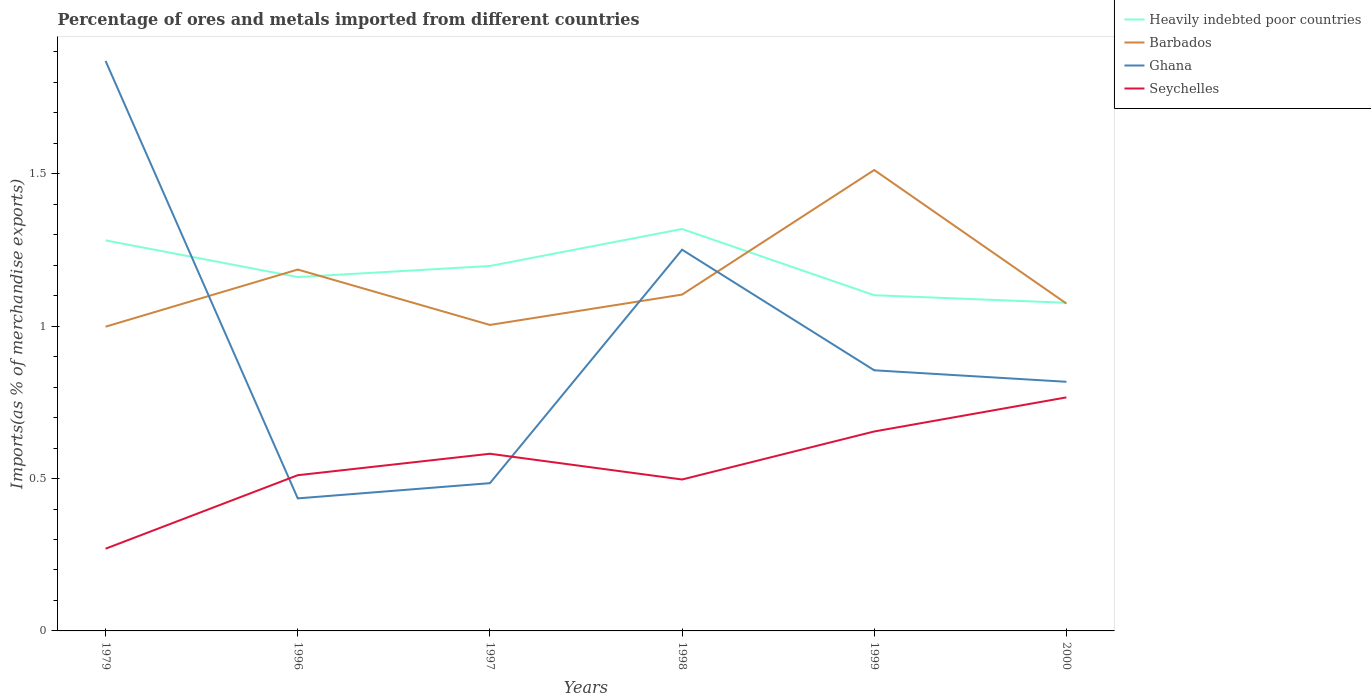How many different coloured lines are there?
Your response must be concise. 4. Is the number of lines equal to the number of legend labels?
Keep it short and to the point. Yes. Across all years, what is the maximum percentage of imports to different countries in Seychelles?
Your response must be concise. 0.27. What is the total percentage of imports to different countries in Heavily indebted poor countries in the graph?
Offer a terse response. 0.24. What is the difference between the highest and the second highest percentage of imports to different countries in Ghana?
Your answer should be compact. 1.44. What is the difference between the highest and the lowest percentage of imports to different countries in Seychelles?
Give a very brief answer. 3. How many lines are there?
Keep it short and to the point. 4. What is the difference between two consecutive major ticks on the Y-axis?
Your answer should be compact. 0.5. Does the graph contain any zero values?
Give a very brief answer. No. Does the graph contain grids?
Your response must be concise. No. Where does the legend appear in the graph?
Ensure brevity in your answer.  Top right. How many legend labels are there?
Your answer should be compact. 4. What is the title of the graph?
Give a very brief answer. Percentage of ores and metals imported from different countries. Does "Mali" appear as one of the legend labels in the graph?
Offer a very short reply. No. What is the label or title of the Y-axis?
Make the answer very short. Imports(as % of merchandise exports). What is the Imports(as % of merchandise exports) of Heavily indebted poor countries in 1979?
Ensure brevity in your answer.  1.28. What is the Imports(as % of merchandise exports) in Barbados in 1979?
Make the answer very short. 1. What is the Imports(as % of merchandise exports) of Ghana in 1979?
Your response must be concise. 1.87. What is the Imports(as % of merchandise exports) of Seychelles in 1979?
Offer a very short reply. 0.27. What is the Imports(as % of merchandise exports) in Heavily indebted poor countries in 1996?
Your answer should be compact. 1.16. What is the Imports(as % of merchandise exports) in Barbados in 1996?
Keep it short and to the point. 1.19. What is the Imports(as % of merchandise exports) in Ghana in 1996?
Offer a terse response. 0.43. What is the Imports(as % of merchandise exports) of Seychelles in 1996?
Keep it short and to the point. 0.51. What is the Imports(as % of merchandise exports) of Heavily indebted poor countries in 1997?
Provide a succinct answer. 1.2. What is the Imports(as % of merchandise exports) of Barbados in 1997?
Make the answer very short. 1. What is the Imports(as % of merchandise exports) of Ghana in 1997?
Offer a terse response. 0.48. What is the Imports(as % of merchandise exports) in Seychelles in 1997?
Provide a short and direct response. 0.58. What is the Imports(as % of merchandise exports) of Heavily indebted poor countries in 1998?
Your answer should be very brief. 1.32. What is the Imports(as % of merchandise exports) in Barbados in 1998?
Your response must be concise. 1.1. What is the Imports(as % of merchandise exports) of Ghana in 1998?
Give a very brief answer. 1.25. What is the Imports(as % of merchandise exports) in Seychelles in 1998?
Your answer should be compact. 0.5. What is the Imports(as % of merchandise exports) of Heavily indebted poor countries in 1999?
Provide a short and direct response. 1.1. What is the Imports(as % of merchandise exports) of Barbados in 1999?
Ensure brevity in your answer.  1.51. What is the Imports(as % of merchandise exports) in Ghana in 1999?
Your answer should be very brief. 0.86. What is the Imports(as % of merchandise exports) of Seychelles in 1999?
Provide a short and direct response. 0.65. What is the Imports(as % of merchandise exports) in Heavily indebted poor countries in 2000?
Keep it short and to the point. 1.08. What is the Imports(as % of merchandise exports) of Barbados in 2000?
Your answer should be very brief. 1.07. What is the Imports(as % of merchandise exports) of Ghana in 2000?
Offer a terse response. 0.82. What is the Imports(as % of merchandise exports) of Seychelles in 2000?
Provide a succinct answer. 0.77. Across all years, what is the maximum Imports(as % of merchandise exports) of Heavily indebted poor countries?
Provide a short and direct response. 1.32. Across all years, what is the maximum Imports(as % of merchandise exports) of Barbados?
Ensure brevity in your answer.  1.51. Across all years, what is the maximum Imports(as % of merchandise exports) in Ghana?
Your answer should be very brief. 1.87. Across all years, what is the maximum Imports(as % of merchandise exports) in Seychelles?
Provide a succinct answer. 0.77. Across all years, what is the minimum Imports(as % of merchandise exports) in Heavily indebted poor countries?
Provide a succinct answer. 1.08. Across all years, what is the minimum Imports(as % of merchandise exports) of Barbados?
Give a very brief answer. 1. Across all years, what is the minimum Imports(as % of merchandise exports) in Ghana?
Give a very brief answer. 0.43. Across all years, what is the minimum Imports(as % of merchandise exports) in Seychelles?
Provide a short and direct response. 0.27. What is the total Imports(as % of merchandise exports) of Heavily indebted poor countries in the graph?
Make the answer very short. 7.14. What is the total Imports(as % of merchandise exports) in Barbados in the graph?
Make the answer very short. 6.88. What is the total Imports(as % of merchandise exports) in Ghana in the graph?
Your answer should be compact. 5.71. What is the total Imports(as % of merchandise exports) of Seychelles in the graph?
Your response must be concise. 3.28. What is the difference between the Imports(as % of merchandise exports) of Heavily indebted poor countries in 1979 and that in 1996?
Your answer should be very brief. 0.12. What is the difference between the Imports(as % of merchandise exports) of Barbados in 1979 and that in 1996?
Provide a short and direct response. -0.19. What is the difference between the Imports(as % of merchandise exports) of Ghana in 1979 and that in 1996?
Offer a terse response. 1.44. What is the difference between the Imports(as % of merchandise exports) of Seychelles in 1979 and that in 1996?
Give a very brief answer. -0.24. What is the difference between the Imports(as % of merchandise exports) of Heavily indebted poor countries in 1979 and that in 1997?
Provide a succinct answer. 0.08. What is the difference between the Imports(as % of merchandise exports) in Barbados in 1979 and that in 1997?
Ensure brevity in your answer.  -0.01. What is the difference between the Imports(as % of merchandise exports) in Ghana in 1979 and that in 1997?
Offer a terse response. 1.39. What is the difference between the Imports(as % of merchandise exports) in Seychelles in 1979 and that in 1997?
Keep it short and to the point. -0.31. What is the difference between the Imports(as % of merchandise exports) of Heavily indebted poor countries in 1979 and that in 1998?
Give a very brief answer. -0.04. What is the difference between the Imports(as % of merchandise exports) of Barbados in 1979 and that in 1998?
Offer a terse response. -0.11. What is the difference between the Imports(as % of merchandise exports) in Ghana in 1979 and that in 1998?
Offer a terse response. 0.62. What is the difference between the Imports(as % of merchandise exports) of Seychelles in 1979 and that in 1998?
Provide a succinct answer. -0.23. What is the difference between the Imports(as % of merchandise exports) of Heavily indebted poor countries in 1979 and that in 1999?
Ensure brevity in your answer.  0.18. What is the difference between the Imports(as % of merchandise exports) in Barbados in 1979 and that in 1999?
Provide a short and direct response. -0.51. What is the difference between the Imports(as % of merchandise exports) in Ghana in 1979 and that in 1999?
Your response must be concise. 1.02. What is the difference between the Imports(as % of merchandise exports) of Seychelles in 1979 and that in 1999?
Keep it short and to the point. -0.38. What is the difference between the Imports(as % of merchandise exports) in Heavily indebted poor countries in 1979 and that in 2000?
Provide a succinct answer. 0.2. What is the difference between the Imports(as % of merchandise exports) of Barbados in 1979 and that in 2000?
Your response must be concise. -0.08. What is the difference between the Imports(as % of merchandise exports) in Ghana in 1979 and that in 2000?
Your answer should be compact. 1.05. What is the difference between the Imports(as % of merchandise exports) in Seychelles in 1979 and that in 2000?
Offer a terse response. -0.5. What is the difference between the Imports(as % of merchandise exports) of Heavily indebted poor countries in 1996 and that in 1997?
Offer a terse response. -0.04. What is the difference between the Imports(as % of merchandise exports) in Barbados in 1996 and that in 1997?
Your response must be concise. 0.18. What is the difference between the Imports(as % of merchandise exports) in Ghana in 1996 and that in 1997?
Provide a succinct answer. -0.05. What is the difference between the Imports(as % of merchandise exports) of Seychelles in 1996 and that in 1997?
Provide a short and direct response. -0.07. What is the difference between the Imports(as % of merchandise exports) in Heavily indebted poor countries in 1996 and that in 1998?
Keep it short and to the point. -0.16. What is the difference between the Imports(as % of merchandise exports) of Barbados in 1996 and that in 1998?
Ensure brevity in your answer.  0.08. What is the difference between the Imports(as % of merchandise exports) in Ghana in 1996 and that in 1998?
Keep it short and to the point. -0.82. What is the difference between the Imports(as % of merchandise exports) in Seychelles in 1996 and that in 1998?
Offer a very short reply. 0.01. What is the difference between the Imports(as % of merchandise exports) of Heavily indebted poor countries in 1996 and that in 1999?
Offer a terse response. 0.06. What is the difference between the Imports(as % of merchandise exports) in Barbados in 1996 and that in 1999?
Your response must be concise. -0.33. What is the difference between the Imports(as % of merchandise exports) of Ghana in 1996 and that in 1999?
Keep it short and to the point. -0.42. What is the difference between the Imports(as % of merchandise exports) of Seychelles in 1996 and that in 1999?
Provide a short and direct response. -0.14. What is the difference between the Imports(as % of merchandise exports) in Heavily indebted poor countries in 1996 and that in 2000?
Keep it short and to the point. 0.08. What is the difference between the Imports(as % of merchandise exports) of Barbados in 1996 and that in 2000?
Make the answer very short. 0.11. What is the difference between the Imports(as % of merchandise exports) in Ghana in 1996 and that in 2000?
Your answer should be compact. -0.38. What is the difference between the Imports(as % of merchandise exports) in Seychelles in 1996 and that in 2000?
Offer a very short reply. -0.26. What is the difference between the Imports(as % of merchandise exports) of Heavily indebted poor countries in 1997 and that in 1998?
Ensure brevity in your answer.  -0.12. What is the difference between the Imports(as % of merchandise exports) in Barbados in 1997 and that in 1998?
Give a very brief answer. -0.1. What is the difference between the Imports(as % of merchandise exports) of Ghana in 1997 and that in 1998?
Ensure brevity in your answer.  -0.77. What is the difference between the Imports(as % of merchandise exports) of Seychelles in 1997 and that in 1998?
Keep it short and to the point. 0.08. What is the difference between the Imports(as % of merchandise exports) of Heavily indebted poor countries in 1997 and that in 1999?
Give a very brief answer. 0.1. What is the difference between the Imports(as % of merchandise exports) of Barbados in 1997 and that in 1999?
Provide a short and direct response. -0.51. What is the difference between the Imports(as % of merchandise exports) of Ghana in 1997 and that in 1999?
Offer a very short reply. -0.37. What is the difference between the Imports(as % of merchandise exports) of Seychelles in 1997 and that in 1999?
Your answer should be very brief. -0.07. What is the difference between the Imports(as % of merchandise exports) in Heavily indebted poor countries in 1997 and that in 2000?
Make the answer very short. 0.12. What is the difference between the Imports(as % of merchandise exports) in Barbados in 1997 and that in 2000?
Your answer should be very brief. -0.07. What is the difference between the Imports(as % of merchandise exports) in Ghana in 1997 and that in 2000?
Provide a succinct answer. -0.33. What is the difference between the Imports(as % of merchandise exports) of Seychelles in 1997 and that in 2000?
Your response must be concise. -0.18. What is the difference between the Imports(as % of merchandise exports) of Heavily indebted poor countries in 1998 and that in 1999?
Your answer should be very brief. 0.22. What is the difference between the Imports(as % of merchandise exports) of Barbados in 1998 and that in 1999?
Give a very brief answer. -0.41. What is the difference between the Imports(as % of merchandise exports) of Ghana in 1998 and that in 1999?
Your response must be concise. 0.4. What is the difference between the Imports(as % of merchandise exports) of Seychelles in 1998 and that in 1999?
Make the answer very short. -0.16. What is the difference between the Imports(as % of merchandise exports) of Heavily indebted poor countries in 1998 and that in 2000?
Give a very brief answer. 0.24. What is the difference between the Imports(as % of merchandise exports) of Barbados in 1998 and that in 2000?
Provide a succinct answer. 0.03. What is the difference between the Imports(as % of merchandise exports) in Ghana in 1998 and that in 2000?
Give a very brief answer. 0.43. What is the difference between the Imports(as % of merchandise exports) of Seychelles in 1998 and that in 2000?
Make the answer very short. -0.27. What is the difference between the Imports(as % of merchandise exports) of Heavily indebted poor countries in 1999 and that in 2000?
Your response must be concise. 0.02. What is the difference between the Imports(as % of merchandise exports) in Barbados in 1999 and that in 2000?
Provide a short and direct response. 0.44. What is the difference between the Imports(as % of merchandise exports) of Ghana in 1999 and that in 2000?
Offer a terse response. 0.04. What is the difference between the Imports(as % of merchandise exports) of Seychelles in 1999 and that in 2000?
Offer a terse response. -0.11. What is the difference between the Imports(as % of merchandise exports) of Heavily indebted poor countries in 1979 and the Imports(as % of merchandise exports) of Barbados in 1996?
Give a very brief answer. 0.1. What is the difference between the Imports(as % of merchandise exports) of Heavily indebted poor countries in 1979 and the Imports(as % of merchandise exports) of Ghana in 1996?
Provide a short and direct response. 0.85. What is the difference between the Imports(as % of merchandise exports) in Heavily indebted poor countries in 1979 and the Imports(as % of merchandise exports) in Seychelles in 1996?
Your response must be concise. 0.77. What is the difference between the Imports(as % of merchandise exports) in Barbados in 1979 and the Imports(as % of merchandise exports) in Ghana in 1996?
Your response must be concise. 0.56. What is the difference between the Imports(as % of merchandise exports) in Barbados in 1979 and the Imports(as % of merchandise exports) in Seychelles in 1996?
Your response must be concise. 0.49. What is the difference between the Imports(as % of merchandise exports) in Ghana in 1979 and the Imports(as % of merchandise exports) in Seychelles in 1996?
Offer a terse response. 1.36. What is the difference between the Imports(as % of merchandise exports) in Heavily indebted poor countries in 1979 and the Imports(as % of merchandise exports) in Barbados in 1997?
Provide a succinct answer. 0.28. What is the difference between the Imports(as % of merchandise exports) of Heavily indebted poor countries in 1979 and the Imports(as % of merchandise exports) of Ghana in 1997?
Give a very brief answer. 0.8. What is the difference between the Imports(as % of merchandise exports) of Heavily indebted poor countries in 1979 and the Imports(as % of merchandise exports) of Seychelles in 1997?
Make the answer very short. 0.7. What is the difference between the Imports(as % of merchandise exports) in Barbados in 1979 and the Imports(as % of merchandise exports) in Ghana in 1997?
Keep it short and to the point. 0.51. What is the difference between the Imports(as % of merchandise exports) of Barbados in 1979 and the Imports(as % of merchandise exports) of Seychelles in 1997?
Keep it short and to the point. 0.42. What is the difference between the Imports(as % of merchandise exports) in Ghana in 1979 and the Imports(as % of merchandise exports) in Seychelles in 1997?
Give a very brief answer. 1.29. What is the difference between the Imports(as % of merchandise exports) in Heavily indebted poor countries in 1979 and the Imports(as % of merchandise exports) in Barbados in 1998?
Ensure brevity in your answer.  0.18. What is the difference between the Imports(as % of merchandise exports) of Heavily indebted poor countries in 1979 and the Imports(as % of merchandise exports) of Ghana in 1998?
Offer a terse response. 0.03. What is the difference between the Imports(as % of merchandise exports) in Heavily indebted poor countries in 1979 and the Imports(as % of merchandise exports) in Seychelles in 1998?
Keep it short and to the point. 0.78. What is the difference between the Imports(as % of merchandise exports) in Barbados in 1979 and the Imports(as % of merchandise exports) in Ghana in 1998?
Your answer should be compact. -0.25. What is the difference between the Imports(as % of merchandise exports) in Barbados in 1979 and the Imports(as % of merchandise exports) in Seychelles in 1998?
Make the answer very short. 0.5. What is the difference between the Imports(as % of merchandise exports) in Ghana in 1979 and the Imports(as % of merchandise exports) in Seychelles in 1998?
Your answer should be very brief. 1.37. What is the difference between the Imports(as % of merchandise exports) of Heavily indebted poor countries in 1979 and the Imports(as % of merchandise exports) of Barbados in 1999?
Provide a succinct answer. -0.23. What is the difference between the Imports(as % of merchandise exports) in Heavily indebted poor countries in 1979 and the Imports(as % of merchandise exports) in Ghana in 1999?
Provide a succinct answer. 0.43. What is the difference between the Imports(as % of merchandise exports) in Heavily indebted poor countries in 1979 and the Imports(as % of merchandise exports) in Seychelles in 1999?
Give a very brief answer. 0.63. What is the difference between the Imports(as % of merchandise exports) of Barbados in 1979 and the Imports(as % of merchandise exports) of Ghana in 1999?
Offer a terse response. 0.14. What is the difference between the Imports(as % of merchandise exports) in Barbados in 1979 and the Imports(as % of merchandise exports) in Seychelles in 1999?
Make the answer very short. 0.34. What is the difference between the Imports(as % of merchandise exports) of Ghana in 1979 and the Imports(as % of merchandise exports) of Seychelles in 1999?
Provide a short and direct response. 1.22. What is the difference between the Imports(as % of merchandise exports) of Heavily indebted poor countries in 1979 and the Imports(as % of merchandise exports) of Barbados in 2000?
Your response must be concise. 0.21. What is the difference between the Imports(as % of merchandise exports) in Heavily indebted poor countries in 1979 and the Imports(as % of merchandise exports) in Ghana in 2000?
Provide a short and direct response. 0.46. What is the difference between the Imports(as % of merchandise exports) in Heavily indebted poor countries in 1979 and the Imports(as % of merchandise exports) in Seychelles in 2000?
Provide a succinct answer. 0.52. What is the difference between the Imports(as % of merchandise exports) in Barbados in 1979 and the Imports(as % of merchandise exports) in Ghana in 2000?
Your response must be concise. 0.18. What is the difference between the Imports(as % of merchandise exports) in Barbados in 1979 and the Imports(as % of merchandise exports) in Seychelles in 2000?
Ensure brevity in your answer.  0.23. What is the difference between the Imports(as % of merchandise exports) in Ghana in 1979 and the Imports(as % of merchandise exports) in Seychelles in 2000?
Your response must be concise. 1.1. What is the difference between the Imports(as % of merchandise exports) of Heavily indebted poor countries in 1996 and the Imports(as % of merchandise exports) of Barbados in 1997?
Ensure brevity in your answer.  0.16. What is the difference between the Imports(as % of merchandise exports) of Heavily indebted poor countries in 1996 and the Imports(as % of merchandise exports) of Ghana in 1997?
Provide a short and direct response. 0.68. What is the difference between the Imports(as % of merchandise exports) in Heavily indebted poor countries in 1996 and the Imports(as % of merchandise exports) in Seychelles in 1997?
Make the answer very short. 0.58. What is the difference between the Imports(as % of merchandise exports) in Barbados in 1996 and the Imports(as % of merchandise exports) in Ghana in 1997?
Your answer should be compact. 0.7. What is the difference between the Imports(as % of merchandise exports) in Barbados in 1996 and the Imports(as % of merchandise exports) in Seychelles in 1997?
Your answer should be very brief. 0.6. What is the difference between the Imports(as % of merchandise exports) of Ghana in 1996 and the Imports(as % of merchandise exports) of Seychelles in 1997?
Make the answer very short. -0.15. What is the difference between the Imports(as % of merchandise exports) of Heavily indebted poor countries in 1996 and the Imports(as % of merchandise exports) of Barbados in 1998?
Provide a short and direct response. 0.06. What is the difference between the Imports(as % of merchandise exports) of Heavily indebted poor countries in 1996 and the Imports(as % of merchandise exports) of Ghana in 1998?
Provide a succinct answer. -0.09. What is the difference between the Imports(as % of merchandise exports) of Heavily indebted poor countries in 1996 and the Imports(as % of merchandise exports) of Seychelles in 1998?
Ensure brevity in your answer.  0.66. What is the difference between the Imports(as % of merchandise exports) of Barbados in 1996 and the Imports(as % of merchandise exports) of Ghana in 1998?
Keep it short and to the point. -0.07. What is the difference between the Imports(as % of merchandise exports) in Barbados in 1996 and the Imports(as % of merchandise exports) in Seychelles in 1998?
Your response must be concise. 0.69. What is the difference between the Imports(as % of merchandise exports) in Ghana in 1996 and the Imports(as % of merchandise exports) in Seychelles in 1998?
Keep it short and to the point. -0.06. What is the difference between the Imports(as % of merchandise exports) in Heavily indebted poor countries in 1996 and the Imports(as % of merchandise exports) in Barbados in 1999?
Your response must be concise. -0.35. What is the difference between the Imports(as % of merchandise exports) in Heavily indebted poor countries in 1996 and the Imports(as % of merchandise exports) in Ghana in 1999?
Give a very brief answer. 0.31. What is the difference between the Imports(as % of merchandise exports) in Heavily indebted poor countries in 1996 and the Imports(as % of merchandise exports) in Seychelles in 1999?
Provide a succinct answer. 0.51. What is the difference between the Imports(as % of merchandise exports) of Barbados in 1996 and the Imports(as % of merchandise exports) of Ghana in 1999?
Your answer should be very brief. 0.33. What is the difference between the Imports(as % of merchandise exports) in Barbados in 1996 and the Imports(as % of merchandise exports) in Seychelles in 1999?
Your answer should be compact. 0.53. What is the difference between the Imports(as % of merchandise exports) of Ghana in 1996 and the Imports(as % of merchandise exports) of Seychelles in 1999?
Make the answer very short. -0.22. What is the difference between the Imports(as % of merchandise exports) in Heavily indebted poor countries in 1996 and the Imports(as % of merchandise exports) in Barbados in 2000?
Make the answer very short. 0.09. What is the difference between the Imports(as % of merchandise exports) in Heavily indebted poor countries in 1996 and the Imports(as % of merchandise exports) in Ghana in 2000?
Provide a short and direct response. 0.34. What is the difference between the Imports(as % of merchandise exports) of Heavily indebted poor countries in 1996 and the Imports(as % of merchandise exports) of Seychelles in 2000?
Your answer should be very brief. 0.39. What is the difference between the Imports(as % of merchandise exports) of Barbados in 1996 and the Imports(as % of merchandise exports) of Ghana in 2000?
Your response must be concise. 0.37. What is the difference between the Imports(as % of merchandise exports) of Barbados in 1996 and the Imports(as % of merchandise exports) of Seychelles in 2000?
Your answer should be compact. 0.42. What is the difference between the Imports(as % of merchandise exports) in Ghana in 1996 and the Imports(as % of merchandise exports) in Seychelles in 2000?
Give a very brief answer. -0.33. What is the difference between the Imports(as % of merchandise exports) of Heavily indebted poor countries in 1997 and the Imports(as % of merchandise exports) of Barbados in 1998?
Offer a very short reply. 0.09. What is the difference between the Imports(as % of merchandise exports) of Heavily indebted poor countries in 1997 and the Imports(as % of merchandise exports) of Ghana in 1998?
Offer a very short reply. -0.05. What is the difference between the Imports(as % of merchandise exports) of Heavily indebted poor countries in 1997 and the Imports(as % of merchandise exports) of Seychelles in 1998?
Provide a short and direct response. 0.7. What is the difference between the Imports(as % of merchandise exports) in Barbados in 1997 and the Imports(as % of merchandise exports) in Ghana in 1998?
Provide a succinct answer. -0.25. What is the difference between the Imports(as % of merchandise exports) in Barbados in 1997 and the Imports(as % of merchandise exports) in Seychelles in 1998?
Give a very brief answer. 0.51. What is the difference between the Imports(as % of merchandise exports) of Ghana in 1997 and the Imports(as % of merchandise exports) of Seychelles in 1998?
Offer a terse response. -0.01. What is the difference between the Imports(as % of merchandise exports) of Heavily indebted poor countries in 1997 and the Imports(as % of merchandise exports) of Barbados in 1999?
Offer a very short reply. -0.31. What is the difference between the Imports(as % of merchandise exports) in Heavily indebted poor countries in 1997 and the Imports(as % of merchandise exports) in Ghana in 1999?
Make the answer very short. 0.34. What is the difference between the Imports(as % of merchandise exports) of Heavily indebted poor countries in 1997 and the Imports(as % of merchandise exports) of Seychelles in 1999?
Provide a short and direct response. 0.54. What is the difference between the Imports(as % of merchandise exports) of Barbados in 1997 and the Imports(as % of merchandise exports) of Ghana in 1999?
Provide a short and direct response. 0.15. What is the difference between the Imports(as % of merchandise exports) in Barbados in 1997 and the Imports(as % of merchandise exports) in Seychelles in 1999?
Provide a succinct answer. 0.35. What is the difference between the Imports(as % of merchandise exports) of Ghana in 1997 and the Imports(as % of merchandise exports) of Seychelles in 1999?
Provide a short and direct response. -0.17. What is the difference between the Imports(as % of merchandise exports) of Heavily indebted poor countries in 1997 and the Imports(as % of merchandise exports) of Barbados in 2000?
Offer a very short reply. 0.12. What is the difference between the Imports(as % of merchandise exports) in Heavily indebted poor countries in 1997 and the Imports(as % of merchandise exports) in Ghana in 2000?
Your answer should be compact. 0.38. What is the difference between the Imports(as % of merchandise exports) in Heavily indebted poor countries in 1997 and the Imports(as % of merchandise exports) in Seychelles in 2000?
Provide a short and direct response. 0.43. What is the difference between the Imports(as % of merchandise exports) of Barbados in 1997 and the Imports(as % of merchandise exports) of Ghana in 2000?
Your answer should be very brief. 0.19. What is the difference between the Imports(as % of merchandise exports) in Barbados in 1997 and the Imports(as % of merchandise exports) in Seychelles in 2000?
Ensure brevity in your answer.  0.24. What is the difference between the Imports(as % of merchandise exports) in Ghana in 1997 and the Imports(as % of merchandise exports) in Seychelles in 2000?
Your response must be concise. -0.28. What is the difference between the Imports(as % of merchandise exports) in Heavily indebted poor countries in 1998 and the Imports(as % of merchandise exports) in Barbados in 1999?
Your answer should be compact. -0.19. What is the difference between the Imports(as % of merchandise exports) in Heavily indebted poor countries in 1998 and the Imports(as % of merchandise exports) in Ghana in 1999?
Your answer should be compact. 0.46. What is the difference between the Imports(as % of merchandise exports) in Heavily indebted poor countries in 1998 and the Imports(as % of merchandise exports) in Seychelles in 1999?
Give a very brief answer. 0.66. What is the difference between the Imports(as % of merchandise exports) in Barbados in 1998 and the Imports(as % of merchandise exports) in Ghana in 1999?
Your answer should be very brief. 0.25. What is the difference between the Imports(as % of merchandise exports) of Barbados in 1998 and the Imports(as % of merchandise exports) of Seychelles in 1999?
Offer a very short reply. 0.45. What is the difference between the Imports(as % of merchandise exports) in Ghana in 1998 and the Imports(as % of merchandise exports) in Seychelles in 1999?
Offer a terse response. 0.6. What is the difference between the Imports(as % of merchandise exports) of Heavily indebted poor countries in 1998 and the Imports(as % of merchandise exports) of Barbados in 2000?
Offer a very short reply. 0.24. What is the difference between the Imports(as % of merchandise exports) of Heavily indebted poor countries in 1998 and the Imports(as % of merchandise exports) of Ghana in 2000?
Give a very brief answer. 0.5. What is the difference between the Imports(as % of merchandise exports) of Heavily indebted poor countries in 1998 and the Imports(as % of merchandise exports) of Seychelles in 2000?
Offer a terse response. 0.55. What is the difference between the Imports(as % of merchandise exports) of Barbados in 1998 and the Imports(as % of merchandise exports) of Ghana in 2000?
Your response must be concise. 0.29. What is the difference between the Imports(as % of merchandise exports) of Barbados in 1998 and the Imports(as % of merchandise exports) of Seychelles in 2000?
Make the answer very short. 0.34. What is the difference between the Imports(as % of merchandise exports) of Ghana in 1998 and the Imports(as % of merchandise exports) of Seychelles in 2000?
Provide a short and direct response. 0.48. What is the difference between the Imports(as % of merchandise exports) of Heavily indebted poor countries in 1999 and the Imports(as % of merchandise exports) of Barbados in 2000?
Keep it short and to the point. 0.03. What is the difference between the Imports(as % of merchandise exports) in Heavily indebted poor countries in 1999 and the Imports(as % of merchandise exports) in Ghana in 2000?
Keep it short and to the point. 0.28. What is the difference between the Imports(as % of merchandise exports) of Heavily indebted poor countries in 1999 and the Imports(as % of merchandise exports) of Seychelles in 2000?
Give a very brief answer. 0.34. What is the difference between the Imports(as % of merchandise exports) in Barbados in 1999 and the Imports(as % of merchandise exports) in Ghana in 2000?
Provide a succinct answer. 0.69. What is the difference between the Imports(as % of merchandise exports) in Barbados in 1999 and the Imports(as % of merchandise exports) in Seychelles in 2000?
Give a very brief answer. 0.75. What is the difference between the Imports(as % of merchandise exports) of Ghana in 1999 and the Imports(as % of merchandise exports) of Seychelles in 2000?
Offer a terse response. 0.09. What is the average Imports(as % of merchandise exports) in Heavily indebted poor countries per year?
Make the answer very short. 1.19. What is the average Imports(as % of merchandise exports) of Barbados per year?
Your answer should be very brief. 1.15. What is the average Imports(as % of merchandise exports) in Seychelles per year?
Offer a very short reply. 0.55. In the year 1979, what is the difference between the Imports(as % of merchandise exports) of Heavily indebted poor countries and Imports(as % of merchandise exports) of Barbados?
Provide a short and direct response. 0.28. In the year 1979, what is the difference between the Imports(as % of merchandise exports) in Heavily indebted poor countries and Imports(as % of merchandise exports) in Ghana?
Your response must be concise. -0.59. In the year 1979, what is the difference between the Imports(as % of merchandise exports) of Heavily indebted poor countries and Imports(as % of merchandise exports) of Seychelles?
Offer a very short reply. 1.01. In the year 1979, what is the difference between the Imports(as % of merchandise exports) of Barbados and Imports(as % of merchandise exports) of Ghana?
Provide a succinct answer. -0.87. In the year 1979, what is the difference between the Imports(as % of merchandise exports) in Barbados and Imports(as % of merchandise exports) in Seychelles?
Make the answer very short. 0.73. In the year 1979, what is the difference between the Imports(as % of merchandise exports) of Ghana and Imports(as % of merchandise exports) of Seychelles?
Provide a succinct answer. 1.6. In the year 1996, what is the difference between the Imports(as % of merchandise exports) of Heavily indebted poor countries and Imports(as % of merchandise exports) of Barbados?
Your answer should be very brief. -0.02. In the year 1996, what is the difference between the Imports(as % of merchandise exports) in Heavily indebted poor countries and Imports(as % of merchandise exports) in Ghana?
Keep it short and to the point. 0.73. In the year 1996, what is the difference between the Imports(as % of merchandise exports) in Heavily indebted poor countries and Imports(as % of merchandise exports) in Seychelles?
Offer a terse response. 0.65. In the year 1996, what is the difference between the Imports(as % of merchandise exports) in Barbados and Imports(as % of merchandise exports) in Ghana?
Provide a short and direct response. 0.75. In the year 1996, what is the difference between the Imports(as % of merchandise exports) of Barbados and Imports(as % of merchandise exports) of Seychelles?
Give a very brief answer. 0.67. In the year 1996, what is the difference between the Imports(as % of merchandise exports) in Ghana and Imports(as % of merchandise exports) in Seychelles?
Offer a very short reply. -0.08. In the year 1997, what is the difference between the Imports(as % of merchandise exports) of Heavily indebted poor countries and Imports(as % of merchandise exports) of Barbados?
Provide a short and direct response. 0.19. In the year 1997, what is the difference between the Imports(as % of merchandise exports) in Heavily indebted poor countries and Imports(as % of merchandise exports) in Ghana?
Keep it short and to the point. 0.71. In the year 1997, what is the difference between the Imports(as % of merchandise exports) of Heavily indebted poor countries and Imports(as % of merchandise exports) of Seychelles?
Give a very brief answer. 0.62. In the year 1997, what is the difference between the Imports(as % of merchandise exports) in Barbados and Imports(as % of merchandise exports) in Ghana?
Offer a very short reply. 0.52. In the year 1997, what is the difference between the Imports(as % of merchandise exports) of Barbados and Imports(as % of merchandise exports) of Seychelles?
Your response must be concise. 0.42. In the year 1997, what is the difference between the Imports(as % of merchandise exports) in Ghana and Imports(as % of merchandise exports) in Seychelles?
Make the answer very short. -0.1. In the year 1998, what is the difference between the Imports(as % of merchandise exports) of Heavily indebted poor countries and Imports(as % of merchandise exports) of Barbados?
Give a very brief answer. 0.22. In the year 1998, what is the difference between the Imports(as % of merchandise exports) of Heavily indebted poor countries and Imports(as % of merchandise exports) of Ghana?
Make the answer very short. 0.07. In the year 1998, what is the difference between the Imports(as % of merchandise exports) of Heavily indebted poor countries and Imports(as % of merchandise exports) of Seychelles?
Keep it short and to the point. 0.82. In the year 1998, what is the difference between the Imports(as % of merchandise exports) in Barbados and Imports(as % of merchandise exports) in Ghana?
Provide a succinct answer. -0.15. In the year 1998, what is the difference between the Imports(as % of merchandise exports) in Barbados and Imports(as % of merchandise exports) in Seychelles?
Offer a very short reply. 0.61. In the year 1998, what is the difference between the Imports(as % of merchandise exports) of Ghana and Imports(as % of merchandise exports) of Seychelles?
Your answer should be very brief. 0.75. In the year 1999, what is the difference between the Imports(as % of merchandise exports) of Heavily indebted poor countries and Imports(as % of merchandise exports) of Barbados?
Keep it short and to the point. -0.41. In the year 1999, what is the difference between the Imports(as % of merchandise exports) in Heavily indebted poor countries and Imports(as % of merchandise exports) in Ghana?
Keep it short and to the point. 0.25. In the year 1999, what is the difference between the Imports(as % of merchandise exports) in Heavily indebted poor countries and Imports(as % of merchandise exports) in Seychelles?
Provide a short and direct response. 0.45. In the year 1999, what is the difference between the Imports(as % of merchandise exports) of Barbados and Imports(as % of merchandise exports) of Ghana?
Provide a succinct answer. 0.66. In the year 1999, what is the difference between the Imports(as % of merchandise exports) in Barbados and Imports(as % of merchandise exports) in Seychelles?
Make the answer very short. 0.86. In the year 1999, what is the difference between the Imports(as % of merchandise exports) in Ghana and Imports(as % of merchandise exports) in Seychelles?
Your answer should be very brief. 0.2. In the year 2000, what is the difference between the Imports(as % of merchandise exports) of Heavily indebted poor countries and Imports(as % of merchandise exports) of Barbados?
Make the answer very short. 0. In the year 2000, what is the difference between the Imports(as % of merchandise exports) of Heavily indebted poor countries and Imports(as % of merchandise exports) of Ghana?
Your answer should be compact. 0.26. In the year 2000, what is the difference between the Imports(as % of merchandise exports) in Heavily indebted poor countries and Imports(as % of merchandise exports) in Seychelles?
Make the answer very short. 0.31. In the year 2000, what is the difference between the Imports(as % of merchandise exports) of Barbados and Imports(as % of merchandise exports) of Ghana?
Offer a terse response. 0.26. In the year 2000, what is the difference between the Imports(as % of merchandise exports) in Barbados and Imports(as % of merchandise exports) in Seychelles?
Make the answer very short. 0.31. In the year 2000, what is the difference between the Imports(as % of merchandise exports) of Ghana and Imports(as % of merchandise exports) of Seychelles?
Your answer should be compact. 0.05. What is the ratio of the Imports(as % of merchandise exports) in Heavily indebted poor countries in 1979 to that in 1996?
Provide a short and direct response. 1.1. What is the ratio of the Imports(as % of merchandise exports) of Barbados in 1979 to that in 1996?
Provide a short and direct response. 0.84. What is the ratio of the Imports(as % of merchandise exports) in Ghana in 1979 to that in 1996?
Give a very brief answer. 4.3. What is the ratio of the Imports(as % of merchandise exports) in Seychelles in 1979 to that in 1996?
Your answer should be very brief. 0.53. What is the ratio of the Imports(as % of merchandise exports) of Heavily indebted poor countries in 1979 to that in 1997?
Your answer should be compact. 1.07. What is the ratio of the Imports(as % of merchandise exports) of Barbados in 1979 to that in 1997?
Offer a terse response. 0.99. What is the ratio of the Imports(as % of merchandise exports) of Ghana in 1979 to that in 1997?
Provide a short and direct response. 3.86. What is the ratio of the Imports(as % of merchandise exports) of Seychelles in 1979 to that in 1997?
Keep it short and to the point. 0.46. What is the ratio of the Imports(as % of merchandise exports) of Heavily indebted poor countries in 1979 to that in 1998?
Make the answer very short. 0.97. What is the ratio of the Imports(as % of merchandise exports) in Barbados in 1979 to that in 1998?
Offer a terse response. 0.9. What is the ratio of the Imports(as % of merchandise exports) in Ghana in 1979 to that in 1998?
Keep it short and to the point. 1.5. What is the ratio of the Imports(as % of merchandise exports) of Seychelles in 1979 to that in 1998?
Your answer should be very brief. 0.54. What is the ratio of the Imports(as % of merchandise exports) of Heavily indebted poor countries in 1979 to that in 1999?
Give a very brief answer. 1.16. What is the ratio of the Imports(as % of merchandise exports) of Barbados in 1979 to that in 1999?
Ensure brevity in your answer.  0.66. What is the ratio of the Imports(as % of merchandise exports) of Ghana in 1979 to that in 1999?
Provide a succinct answer. 2.19. What is the ratio of the Imports(as % of merchandise exports) of Seychelles in 1979 to that in 1999?
Your answer should be compact. 0.41. What is the ratio of the Imports(as % of merchandise exports) of Heavily indebted poor countries in 1979 to that in 2000?
Ensure brevity in your answer.  1.19. What is the ratio of the Imports(as % of merchandise exports) in Barbados in 1979 to that in 2000?
Provide a short and direct response. 0.93. What is the ratio of the Imports(as % of merchandise exports) in Ghana in 1979 to that in 2000?
Your answer should be compact. 2.29. What is the ratio of the Imports(as % of merchandise exports) of Seychelles in 1979 to that in 2000?
Ensure brevity in your answer.  0.35. What is the ratio of the Imports(as % of merchandise exports) in Heavily indebted poor countries in 1996 to that in 1997?
Your answer should be very brief. 0.97. What is the ratio of the Imports(as % of merchandise exports) in Barbados in 1996 to that in 1997?
Your response must be concise. 1.18. What is the ratio of the Imports(as % of merchandise exports) in Ghana in 1996 to that in 1997?
Keep it short and to the point. 0.9. What is the ratio of the Imports(as % of merchandise exports) in Seychelles in 1996 to that in 1997?
Provide a short and direct response. 0.88. What is the ratio of the Imports(as % of merchandise exports) of Heavily indebted poor countries in 1996 to that in 1998?
Offer a terse response. 0.88. What is the ratio of the Imports(as % of merchandise exports) in Barbados in 1996 to that in 1998?
Offer a very short reply. 1.07. What is the ratio of the Imports(as % of merchandise exports) in Ghana in 1996 to that in 1998?
Your response must be concise. 0.35. What is the ratio of the Imports(as % of merchandise exports) in Seychelles in 1996 to that in 1998?
Offer a terse response. 1.03. What is the ratio of the Imports(as % of merchandise exports) of Heavily indebted poor countries in 1996 to that in 1999?
Offer a terse response. 1.05. What is the ratio of the Imports(as % of merchandise exports) in Barbados in 1996 to that in 1999?
Offer a very short reply. 0.78. What is the ratio of the Imports(as % of merchandise exports) in Ghana in 1996 to that in 1999?
Your response must be concise. 0.51. What is the ratio of the Imports(as % of merchandise exports) of Seychelles in 1996 to that in 1999?
Your response must be concise. 0.78. What is the ratio of the Imports(as % of merchandise exports) of Heavily indebted poor countries in 1996 to that in 2000?
Offer a terse response. 1.08. What is the ratio of the Imports(as % of merchandise exports) of Barbados in 1996 to that in 2000?
Provide a short and direct response. 1.1. What is the ratio of the Imports(as % of merchandise exports) of Ghana in 1996 to that in 2000?
Your answer should be compact. 0.53. What is the ratio of the Imports(as % of merchandise exports) of Seychelles in 1996 to that in 2000?
Give a very brief answer. 0.67. What is the ratio of the Imports(as % of merchandise exports) in Heavily indebted poor countries in 1997 to that in 1998?
Offer a terse response. 0.91. What is the ratio of the Imports(as % of merchandise exports) in Barbados in 1997 to that in 1998?
Ensure brevity in your answer.  0.91. What is the ratio of the Imports(as % of merchandise exports) in Ghana in 1997 to that in 1998?
Ensure brevity in your answer.  0.39. What is the ratio of the Imports(as % of merchandise exports) of Seychelles in 1997 to that in 1998?
Provide a short and direct response. 1.17. What is the ratio of the Imports(as % of merchandise exports) in Heavily indebted poor countries in 1997 to that in 1999?
Your answer should be very brief. 1.09. What is the ratio of the Imports(as % of merchandise exports) of Barbados in 1997 to that in 1999?
Offer a terse response. 0.66. What is the ratio of the Imports(as % of merchandise exports) in Ghana in 1997 to that in 1999?
Keep it short and to the point. 0.57. What is the ratio of the Imports(as % of merchandise exports) in Seychelles in 1997 to that in 1999?
Your answer should be compact. 0.89. What is the ratio of the Imports(as % of merchandise exports) of Heavily indebted poor countries in 1997 to that in 2000?
Offer a very short reply. 1.11. What is the ratio of the Imports(as % of merchandise exports) of Barbados in 1997 to that in 2000?
Your response must be concise. 0.93. What is the ratio of the Imports(as % of merchandise exports) of Ghana in 1997 to that in 2000?
Provide a succinct answer. 0.59. What is the ratio of the Imports(as % of merchandise exports) in Seychelles in 1997 to that in 2000?
Keep it short and to the point. 0.76. What is the ratio of the Imports(as % of merchandise exports) in Heavily indebted poor countries in 1998 to that in 1999?
Keep it short and to the point. 1.2. What is the ratio of the Imports(as % of merchandise exports) of Barbados in 1998 to that in 1999?
Keep it short and to the point. 0.73. What is the ratio of the Imports(as % of merchandise exports) of Ghana in 1998 to that in 1999?
Your answer should be compact. 1.46. What is the ratio of the Imports(as % of merchandise exports) of Seychelles in 1998 to that in 1999?
Provide a short and direct response. 0.76. What is the ratio of the Imports(as % of merchandise exports) of Heavily indebted poor countries in 1998 to that in 2000?
Give a very brief answer. 1.23. What is the ratio of the Imports(as % of merchandise exports) in Barbados in 1998 to that in 2000?
Your answer should be very brief. 1.03. What is the ratio of the Imports(as % of merchandise exports) of Ghana in 1998 to that in 2000?
Offer a very short reply. 1.53. What is the ratio of the Imports(as % of merchandise exports) of Seychelles in 1998 to that in 2000?
Your response must be concise. 0.65. What is the ratio of the Imports(as % of merchandise exports) in Heavily indebted poor countries in 1999 to that in 2000?
Your response must be concise. 1.02. What is the ratio of the Imports(as % of merchandise exports) in Barbados in 1999 to that in 2000?
Offer a very short reply. 1.41. What is the ratio of the Imports(as % of merchandise exports) in Ghana in 1999 to that in 2000?
Offer a very short reply. 1.05. What is the ratio of the Imports(as % of merchandise exports) of Seychelles in 1999 to that in 2000?
Your answer should be compact. 0.85. What is the difference between the highest and the second highest Imports(as % of merchandise exports) in Heavily indebted poor countries?
Ensure brevity in your answer.  0.04. What is the difference between the highest and the second highest Imports(as % of merchandise exports) in Barbados?
Provide a short and direct response. 0.33. What is the difference between the highest and the second highest Imports(as % of merchandise exports) of Ghana?
Offer a terse response. 0.62. What is the difference between the highest and the second highest Imports(as % of merchandise exports) in Seychelles?
Your response must be concise. 0.11. What is the difference between the highest and the lowest Imports(as % of merchandise exports) in Heavily indebted poor countries?
Offer a terse response. 0.24. What is the difference between the highest and the lowest Imports(as % of merchandise exports) in Barbados?
Make the answer very short. 0.51. What is the difference between the highest and the lowest Imports(as % of merchandise exports) of Ghana?
Give a very brief answer. 1.44. What is the difference between the highest and the lowest Imports(as % of merchandise exports) of Seychelles?
Ensure brevity in your answer.  0.5. 